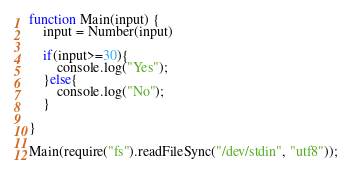Convert code to text. <code><loc_0><loc_0><loc_500><loc_500><_JavaScript_>function Main(input) {
    input = Number(input)
  	
  	if(input>=30){
    	console.log("Yes");
    }else{
    	console.log("No");
    }
	
}

Main(require("fs").readFileSync("/dev/stdin", "utf8"));</code> 